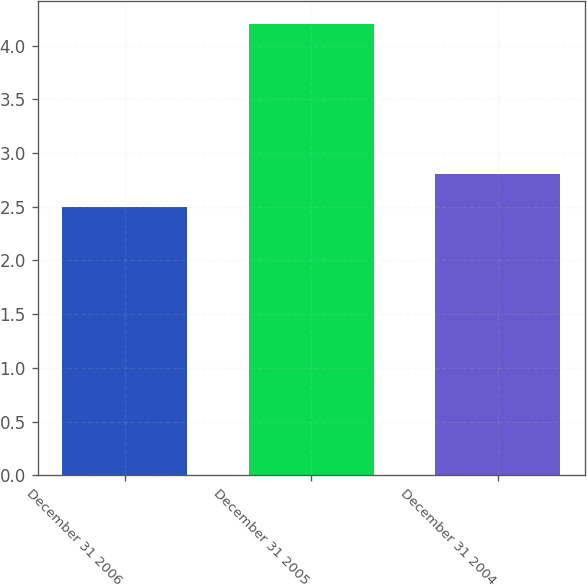<chart> <loc_0><loc_0><loc_500><loc_500><bar_chart><fcel>December 31 2006<fcel>December 31 2005<fcel>December 31 2004<nl><fcel>2.5<fcel>4.2<fcel>2.8<nl></chart> 